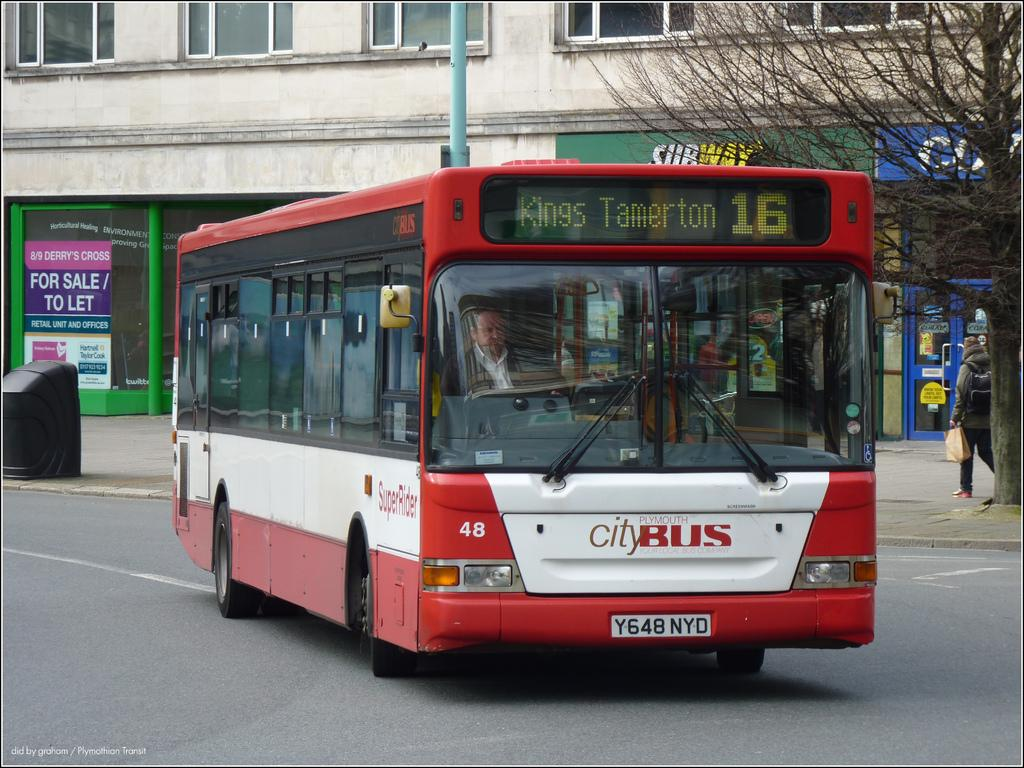<image>
Offer a succinct explanation of the picture presented. A red city bus is going to Kings Tamerton. 